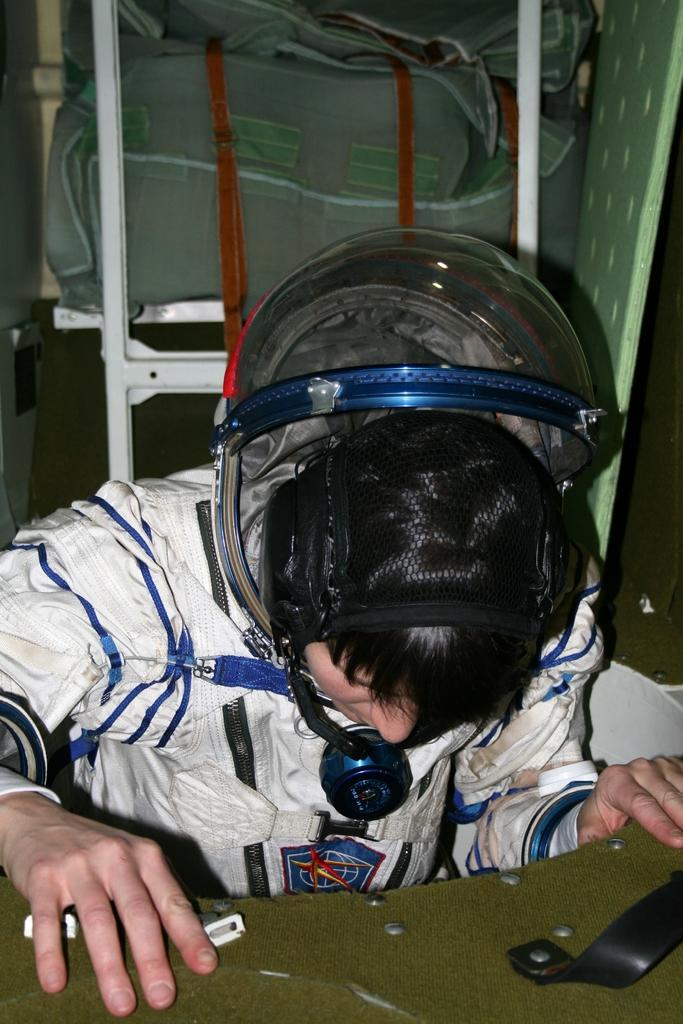Who is present in the image? There is a man in the image. What is the man wearing? The man is wearing a space suit. What is on the man's head? The man has a helmet on his head. What can be seen in front of the man? There is a green surface in front of the man. What is visible in the background? There are white poles with bags in the background. How many children are playing with the man's tail in the image? There is no tail present in the image, and therefore no children can be seen playing with it. 